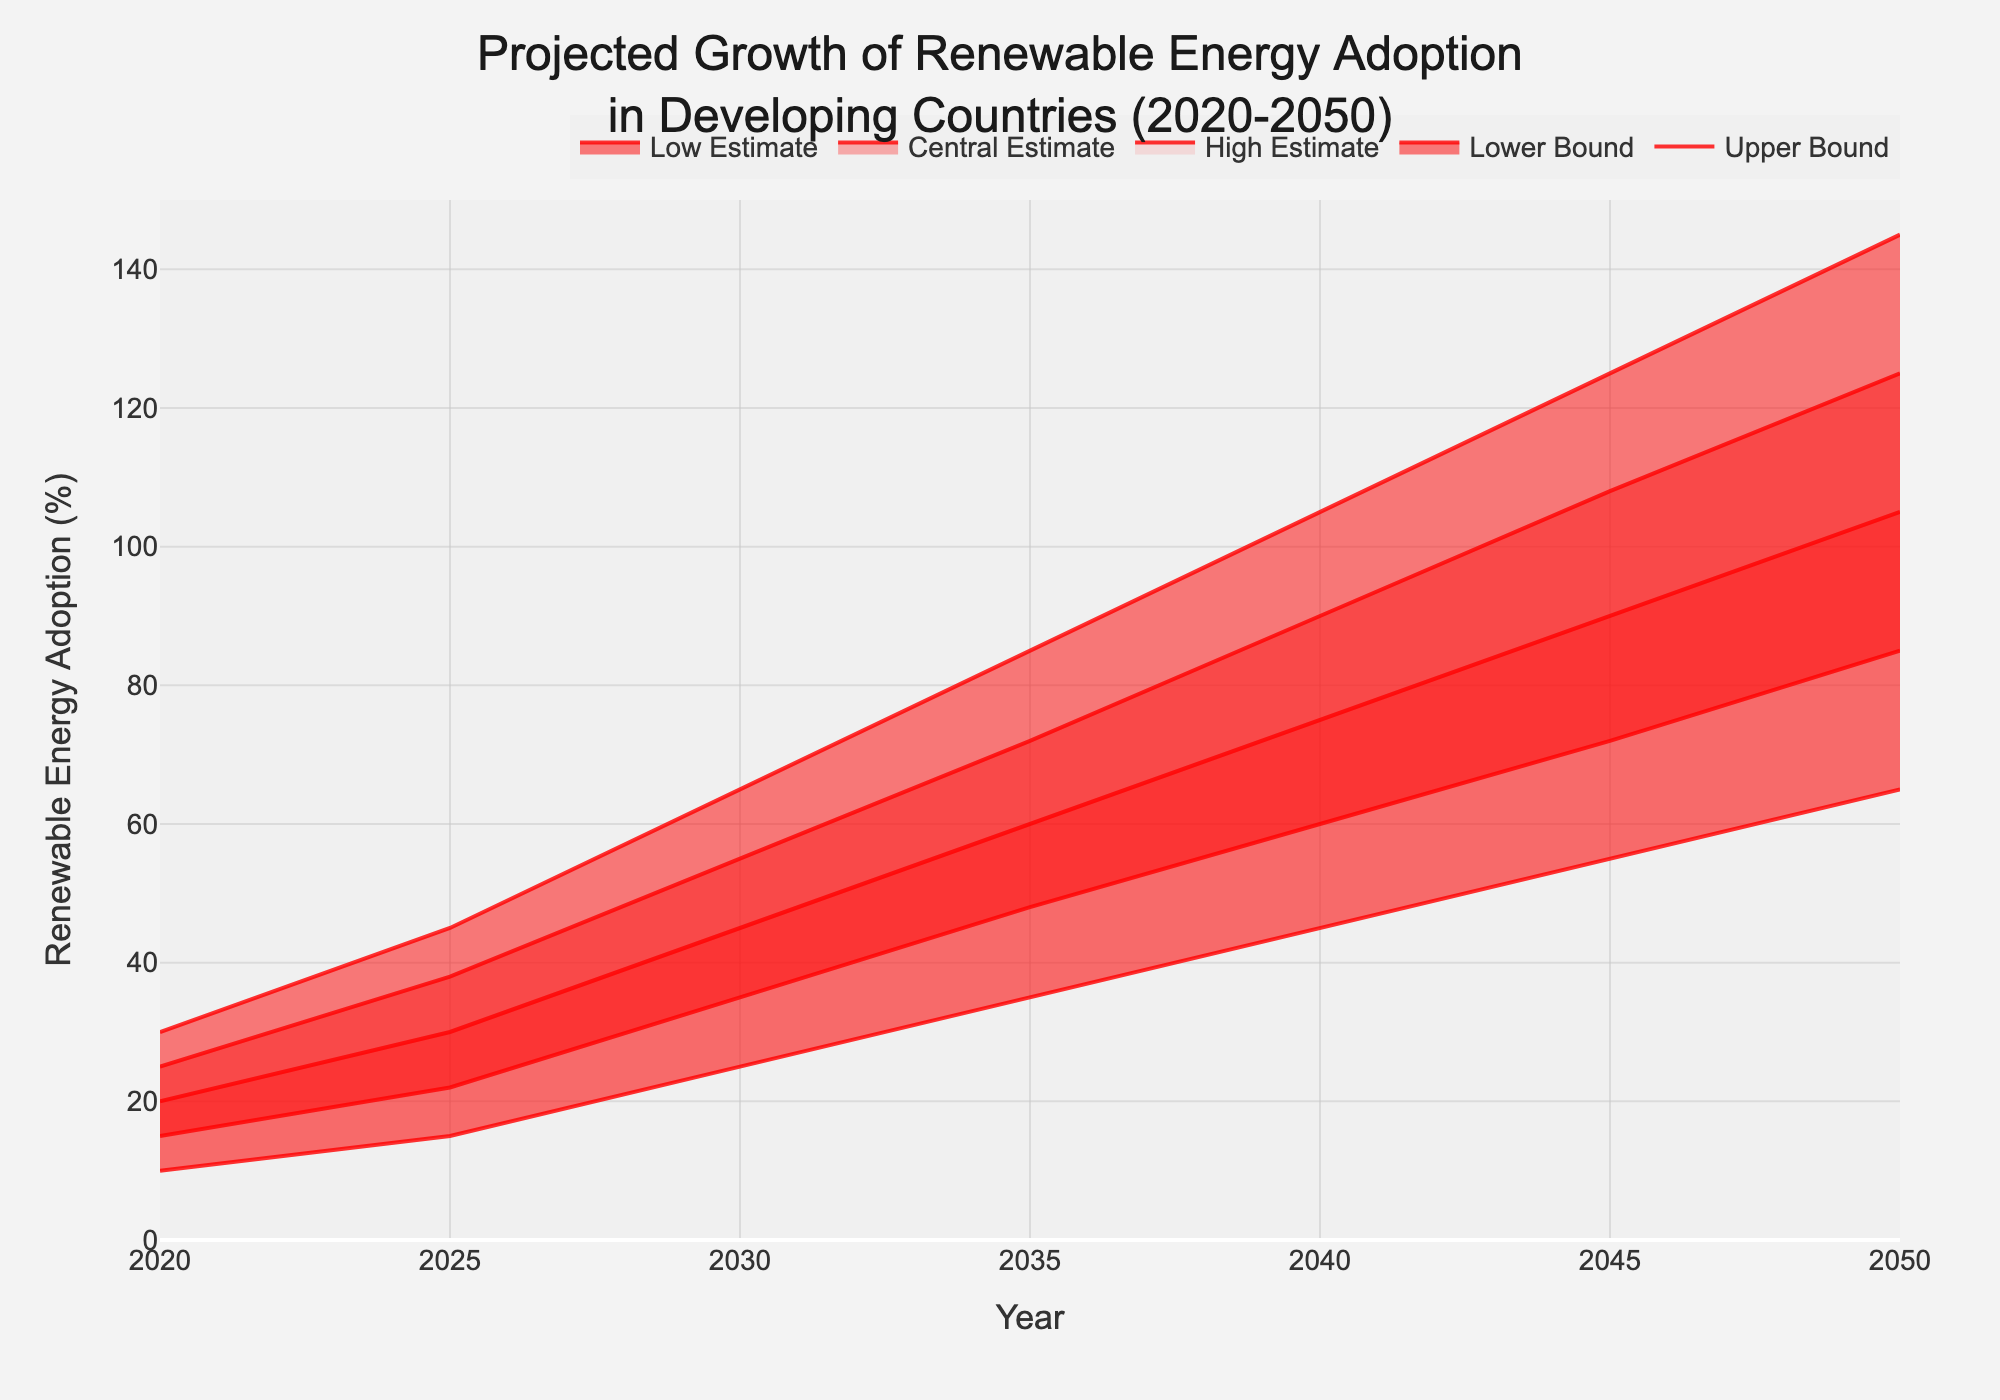What's the title of the figure? The title of the figure is located at the top of the plot, usually in a large font size to make it noticeable.
Answer: Projected Growth of Renewable Energy Adoption in Developing Countries (2020-2050) What is the projected range for renewable energy adoption in 2020? To find this, locate the year 2020 on the x-axis and check the range between the Lower Bound and Upper Bound values on the y-axis.
Answer: 10% to 30% How does the Central Estimate change from 2020 to 2050? Identify the Central Estimate values for the years 2020 and 2050 on the y-axis, then calculate the difference between these values.
Answer: It increases from 20% to 105% In which year does the Lower Bound reach 45%? Locate 45% on the y-axis and trace horizontally to find the corresponding year on the x-axis where the Lower Bound line intersects.
Answer: 2040 What are the colors of the different fill areas in the chart? Identify the fill colors used between different estimates in the chart. Note the varying shades.
Answer: Light to dark shades of red What is the difference in the Upper Bound between the years 2040 and 2050? Locate the Upper Bound values for 2040 and 2050, then subtract the 2040 value from the 2050 value.
Answer: 40% (145% - 105%) What year shows the greatest increase in the Central Estimate compared to the previous year? Inspect the Central Estimate values year by year and identify the largest single-year increase through subtraction.
Answer: 2030 (10% increase from 2025’s 30% to 2030’s 45%) Which year has the smallest interquartile range (difference between High Estimate and Low Estimate)? For each year, calculate the difference between the High Estimate and Low Estimate, then find the year with the smallest difference.
Answer: 2020 (10% difference between 25% and 15%) Does the High Estimate ever exceed the Upper Bound? Compare the High Estimate and Upper Bound values across all years to see if the High Estimate exceeds the Upper Bound at any point.
Answer: No Describe the general trend of renewable energy adoption from 2020 to 2050 according to the Central Estimate. Observe the Central Estimate line from 2020 to 2050 to understand the overall trend.
Answer: It shows a consistent increase 